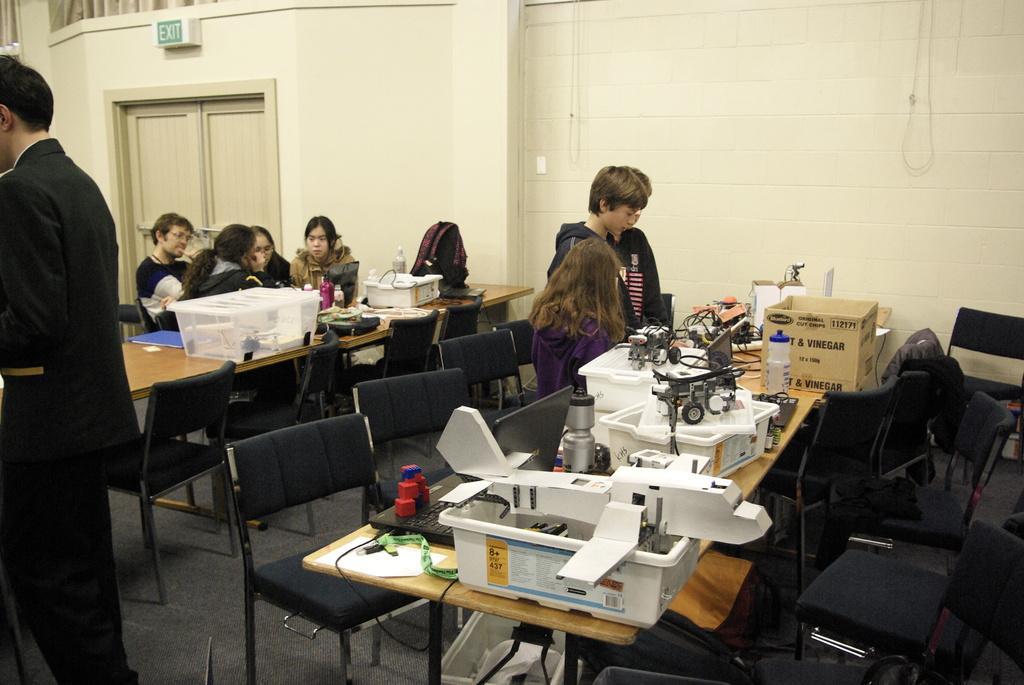Could you give a brief overview of what you see in this image? In this image there are group of people some are sitting and some are standing. There are some machines,bottle,cart board on the table. There are some chairs in the image. At the background there is a wall. a door and a exit board. 